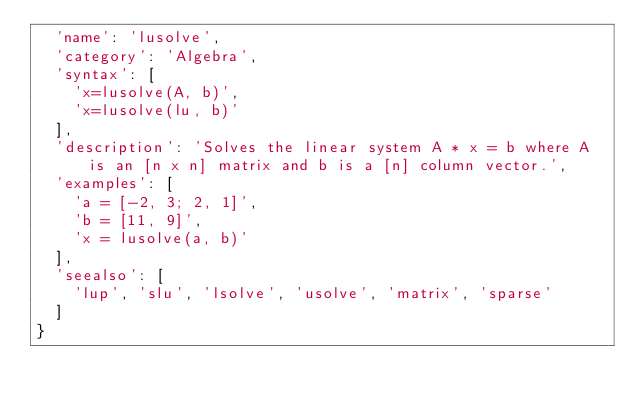<code> <loc_0><loc_0><loc_500><loc_500><_JavaScript_>  'name': 'lusolve',
  'category': 'Algebra',
  'syntax': [
    'x=lusolve(A, b)',
    'x=lusolve(lu, b)'
  ],
  'description': 'Solves the linear system A * x = b where A is an [n x n] matrix and b is a [n] column vector.',
  'examples': [
    'a = [-2, 3; 2, 1]',
    'b = [11, 9]',
    'x = lusolve(a, b)'
  ],
  'seealso': [
    'lup', 'slu', 'lsolve', 'usolve', 'matrix', 'sparse'
  ]
}
</code> 